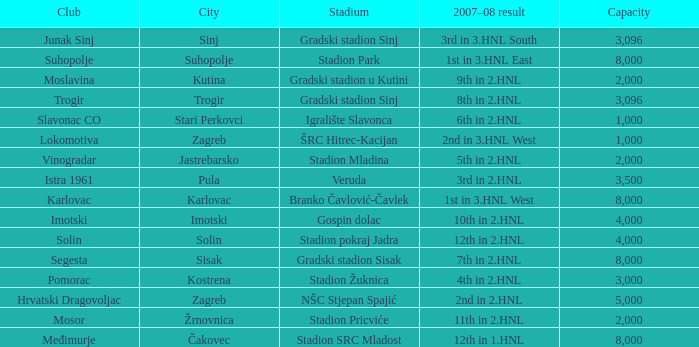What stadium has 9th in 2.hnl as the 2007-08 result? Gradski stadion u Kutini. 